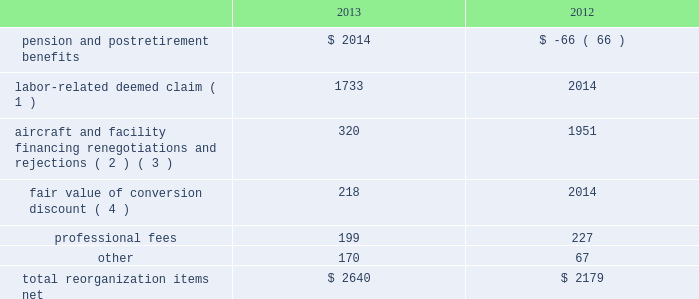Table of contents interest expense , net of capitalized interest increased $ 64 million , or 9.8% ( 9.8 % ) , to $ 710 million in 2013 from $ 646 million in 2012 primarily due to special charges of $ 92 million to recognize post-petition interest expense on unsecured obligations pursuant to the plan and penalty interest related to 10.5% ( 10.5 % ) secured notes and 7.50% ( 7.50 % ) senior secured notes .
Other nonoperating expense , net of $ 84 million in 2013 consists principally of net foreign currency losses of $ 55 million and early debt extinguishment charges of $ 48 million .
Other nonoperating income in 2012 consisted principally of a $ 280 million special credit related to the settlement of a commercial dispute partially offset by net foreign currency losses .
Reorganization items , net reorganization items refer to revenues , expenses ( including professional fees ) , realized gains and losses and provisions for losses that are realized or incurred as a direct result of the chapter 11 cases .
The table summarizes the components included in reorganization items , net on american 2019s consolidated statements of operations for the years ended december 31 , 2013 and 2012 ( in millions ) : .
( 1 ) in exchange for employees 2019 contributions to the successful reorganization , including agreeing to reductions in pay and benefits , american agreed in the plan to provide each employee group a deemed claim , which was used to provide a distribution of a portion of the equity of the reorganized entity to those employees .
Each employee group received a deemed claim amount based upon a portion of the value of cost savings provided by that group through reductions to pay and benefits as well as through certain work rule changes .
The total value of this deemed claim was approximately $ 1.7 billion .
( 2 ) amounts include allowed claims ( claims approved by the bankruptcy court ) and estimated allowed claims relating to ( i ) the rejection or modification of financings related to aircraft and ( ii ) entry of orders treated as unsecured claims with respect to facility agreements supporting certain issuances of special facility revenue bonds .
The debtors recorded an estimated claim associated with the rejection or modification of a financing or facility agreement when the applicable motion was filed with the bankruptcy court to reject or modify such financing or facility agreement and the debtors believed that it was probable the motion would be approved , and there was sufficient information to estimate the claim .
See note 2 to american 2019s consolidated financial statements in part ii , item 8b for further information .
( 3 ) pursuant to the plan , the debtors agreed to allow certain post-petition unsecured claims on obligations .
As a result , during the year ended december 31 , 2013 , american recorded reorganization charges to adjust estimated allowed claim amounts previously recorded on rejected special facility revenue bonds of $ 180 million , allowed general unsecured claims related to the 1990 and 1994 series of special facility revenue bonds that financed certain improvements at jfk , and rejected bonds that financed certain improvements at ord , which are included in the table above .
( 4 ) the plan allowed unsecured creditors receiving aag series a preferred stock a conversion discount of 3.5% ( 3.5 % ) .
Accordingly , american recorded the fair value of such discount upon the confirmation of the plan by the bankruptcy court. .
By how much did total reorganization items net increase from 2012 to 2013? 
Computations: ((2640 - 2179) / 2179)
Answer: 0.21156. 